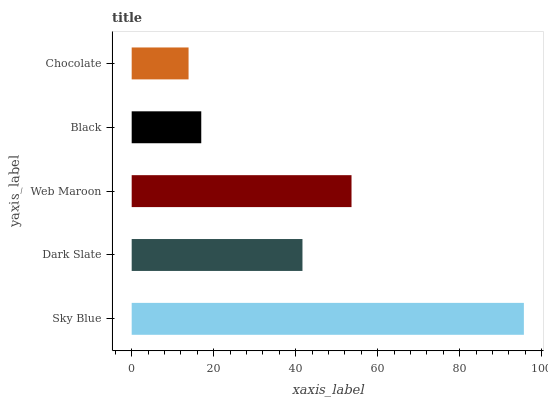Is Chocolate the minimum?
Answer yes or no. Yes. Is Sky Blue the maximum?
Answer yes or no. Yes. Is Dark Slate the minimum?
Answer yes or no. No. Is Dark Slate the maximum?
Answer yes or no. No. Is Sky Blue greater than Dark Slate?
Answer yes or no. Yes. Is Dark Slate less than Sky Blue?
Answer yes or no. Yes. Is Dark Slate greater than Sky Blue?
Answer yes or no. No. Is Sky Blue less than Dark Slate?
Answer yes or no. No. Is Dark Slate the high median?
Answer yes or no. Yes. Is Dark Slate the low median?
Answer yes or no. Yes. Is Chocolate the high median?
Answer yes or no. No. Is Black the low median?
Answer yes or no. No. 